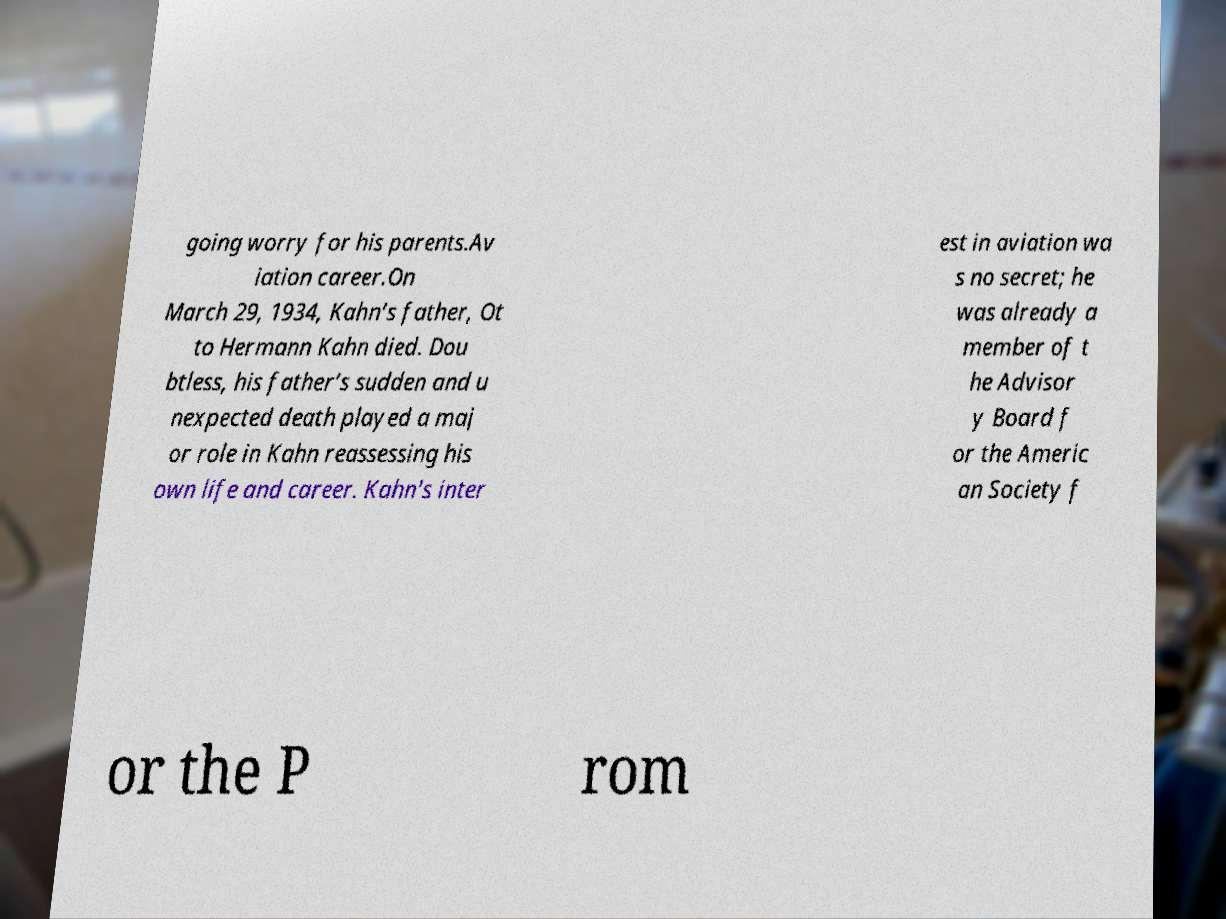I need the written content from this picture converted into text. Can you do that? going worry for his parents.Av iation career.On March 29, 1934, Kahn’s father, Ot to Hermann Kahn died. Dou btless, his father’s sudden and u nexpected death played a maj or role in Kahn reassessing his own life and career. Kahn's inter est in aviation wa s no secret; he was already a member of t he Advisor y Board f or the Americ an Society f or the P rom 